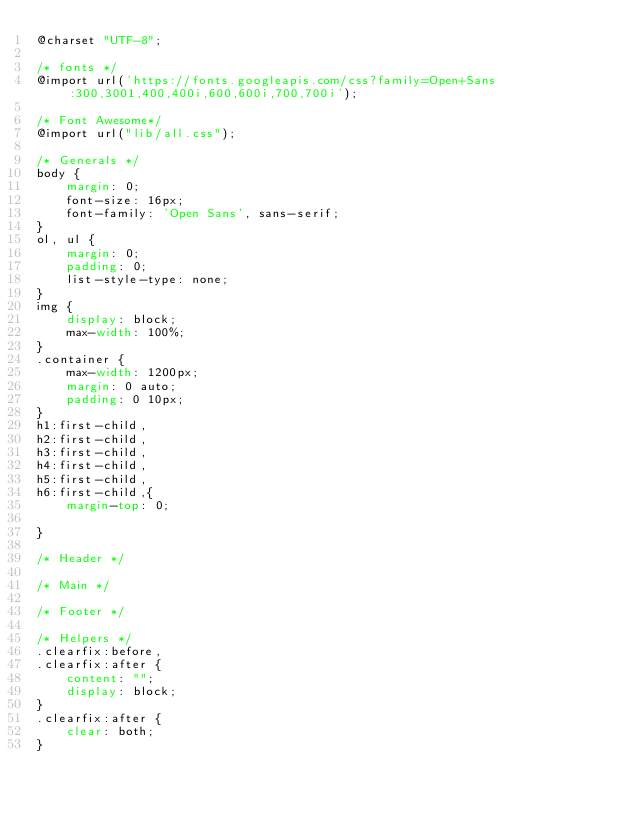<code> <loc_0><loc_0><loc_500><loc_500><_CSS_>@charset "UTF-8";

/* fonts */
@import url('https://fonts.googleapis.com/css?family=Open+Sans:300,3001,400,400i,600,600i,700,700i');

/* Font Awesome*/
@import url("lib/all.css"); 

/* Generals */
body {
    margin: 0;
    font-size: 16px;
    font-family: 'Open Sans', sans-serif;
}
ol, ul {
    margin: 0;
    padding: 0;
    list-style-type: none;
}
img {
    display: block;
    max-width: 100%;
}
.container {
    max-width: 1200px;
    margin: 0 auto;
    padding: 0 10px;
}
h1:first-child, 
h2:first-child,
h3:first-child,
h4:first-child,
h5:first-child,
h6:first-child,{
    margin-top: 0; 

}

/* Header */

/* Main */

/* Footer */

/* Helpers */
.clearfix:before,
.clearfix:after {
    content: "";
    display: block;
}
.clearfix:after {
    clear: both;
}</code> 